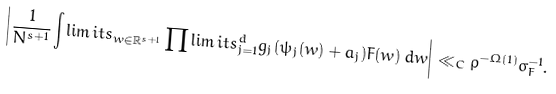<formula> <loc_0><loc_0><loc_500><loc_500>\left | \frac { 1 } { N ^ { s + 1 } } \int \lim i t s _ { w \in \mathbb { R } ^ { s + 1 } } \prod \lim i t s _ { j = 1 } ^ { d } g _ { j } ( \psi _ { j } ( w ) + a _ { j } ) F ( w ) \, d w \right | \ll _ { C } \rho ^ { - \Omega ( 1 ) } \sigma _ { F } ^ { - 1 } .</formula> 